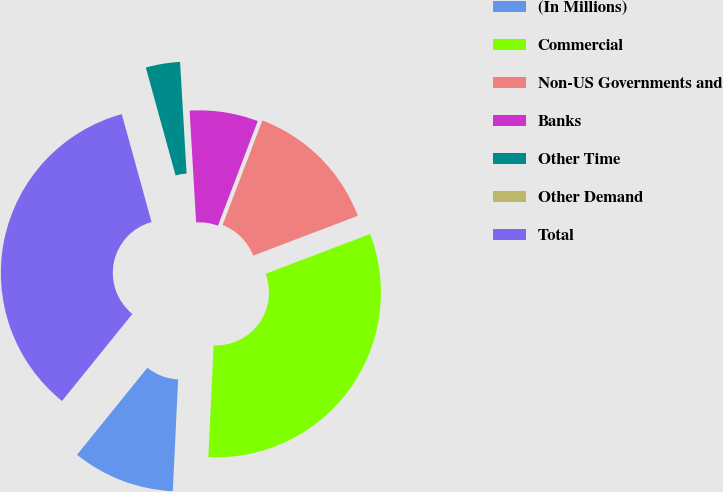Convert chart. <chart><loc_0><loc_0><loc_500><loc_500><pie_chart><fcel>(In Millions)<fcel>Commercial<fcel>Non-US Governments and<fcel>Banks<fcel>Other Time<fcel>Other Demand<fcel>Total<nl><fcel>10.07%<fcel>31.54%<fcel>13.43%<fcel>6.71%<fcel>3.36%<fcel>0.0%<fcel>34.89%<nl></chart> 